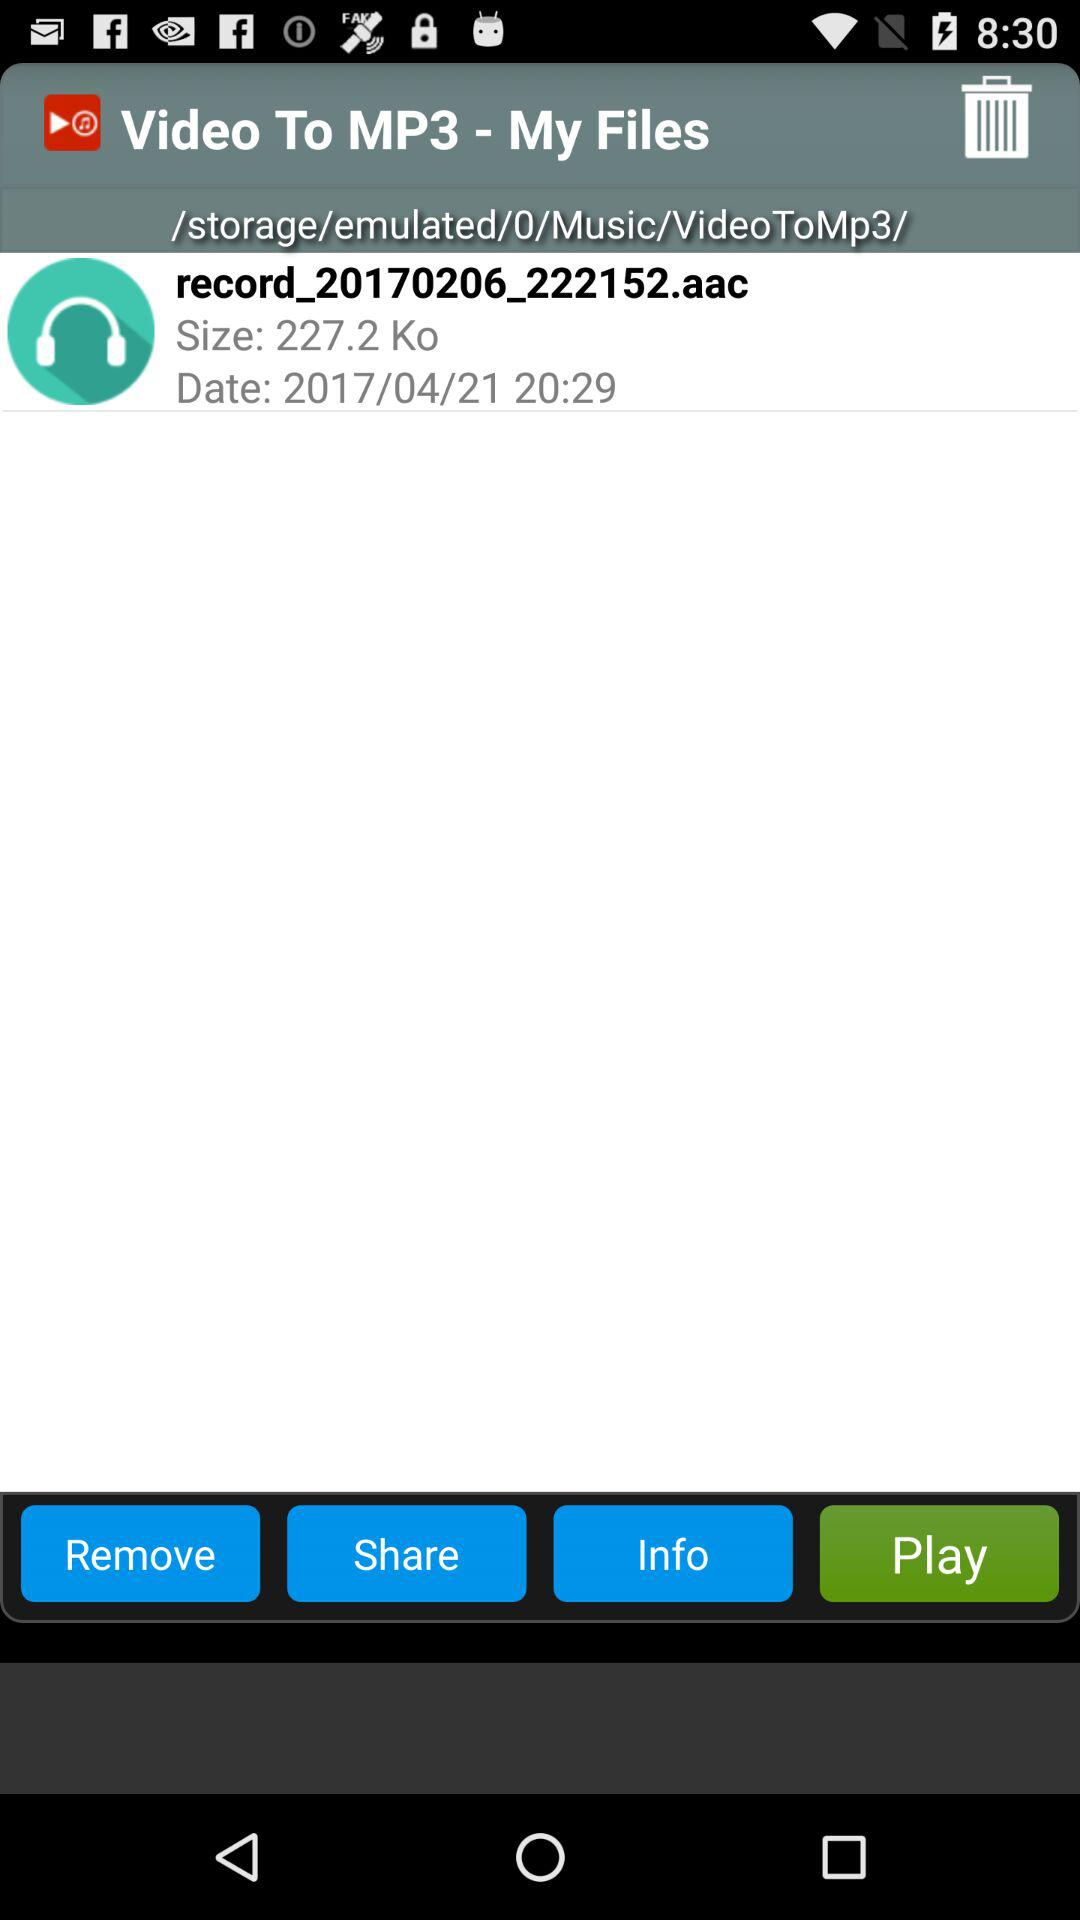What is the size of the file in Kilobytes?
Answer the question using a single word or phrase. 227.2 